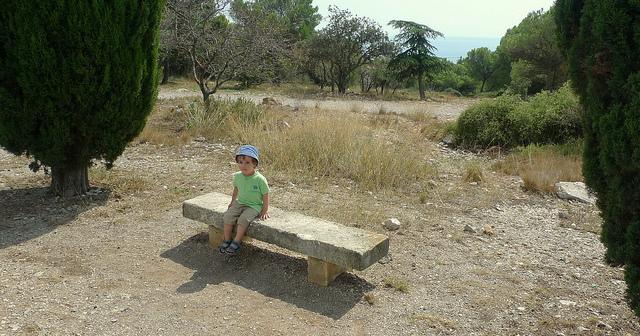What shadow is cast on the tree?
Be succinct. None. What color shirt is the boy wearing?
Be succinct. Green. How many bicycles are in the picture?
Keep it brief. 0. Is the boy on a wooden bench?
Short answer required. No. What material is the bench made of?
Concise answer only. Concrete. 